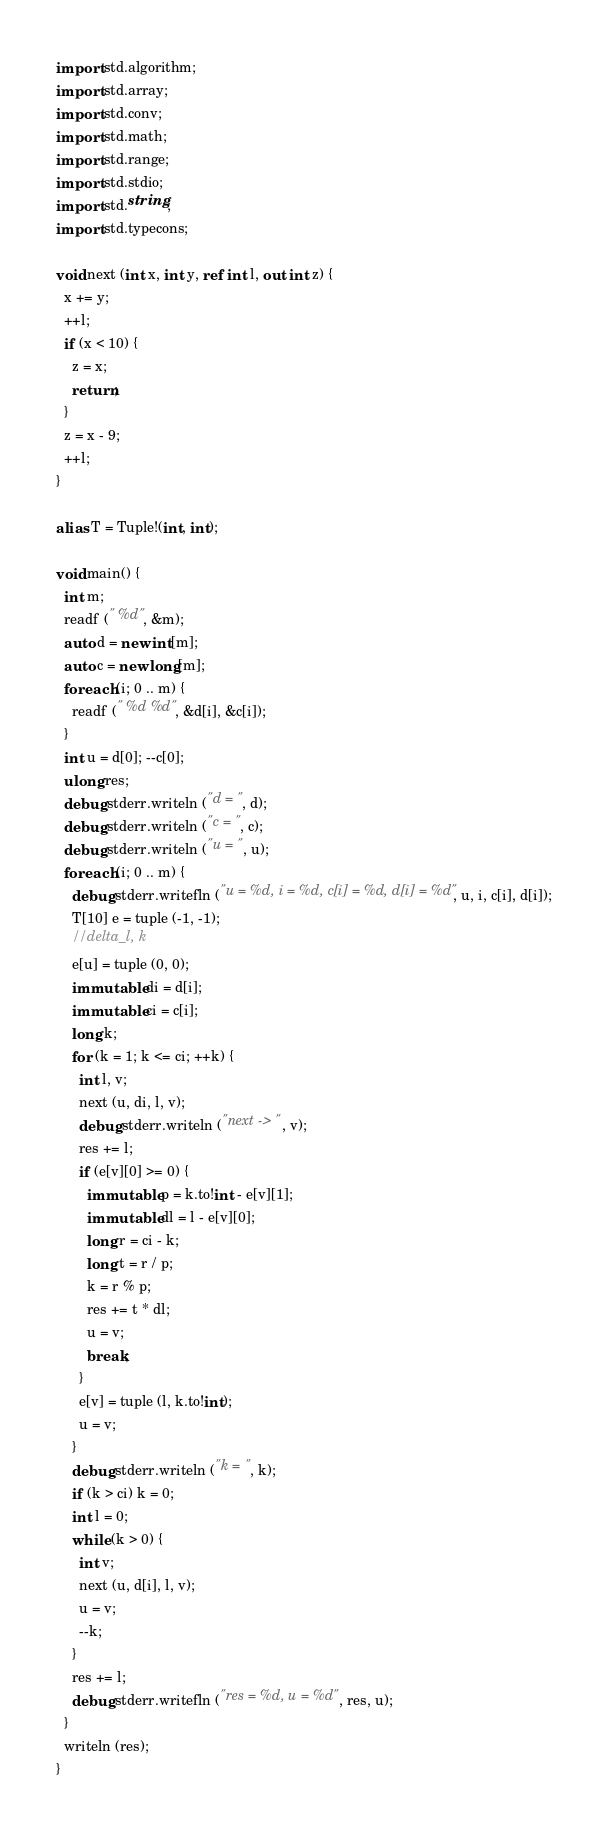Convert code to text. <code><loc_0><loc_0><loc_500><loc_500><_D_>import std.algorithm;
import std.array;
import std.conv;
import std.math;
import std.range;
import std.stdio;
import std.string;
import std.typecons;

void next (int x, int y, ref int l, out int z) {
  x += y;
  ++l;
  if (x < 10) {
    z = x;
    return;
  }
  z = x - 9;
  ++l;
}

alias T = Tuple!(int, int);

void main() {
  int m;
  readf (" %d", &m);
  auto d = new int[m];
  auto c = new long[m];
  foreach (i; 0 .. m) {
    readf (" %d %d", &d[i], &c[i]);
  }
  int u = d[0]; --c[0];
  ulong res;
  debug stderr.writeln ("d = ", d);
  debug stderr.writeln ("c = ", c);
  debug stderr.writeln ("u = ", u);
  foreach (i; 0 .. m) {
    debug stderr.writefln ("u = %d, i = %d, c[i] = %d, d[i] = %d", u, i, c[i], d[i]);
    T[10] e = tuple (-1, -1);
    //delta_l, k
    e[u] = tuple (0, 0);
    immutable di = d[i];
    immutable ci = c[i];
    long k;
    for (k = 1; k <= ci; ++k) {
      int l, v;
      next (u, di, l, v);
      debug stderr.writeln ("next -> ", v);
      res += l;
      if (e[v][0] >= 0) {
        immutable p = k.to!int - e[v][1];
        immutable dl = l - e[v][0]; 
        long r = ci - k;
        long t = r / p;
        k = r % p;
        res += t * dl;
        u = v;
        break;
      }
      e[v] = tuple (l, k.to!int);
      u = v;
    }
    debug stderr.writeln ("k = ", k);
    if (k > ci) k = 0;
    int l = 0;
    while (k > 0) {
      int v;
      next (u, d[i], l, v);
      u = v;
      --k;
    }
    res += l;
    debug stderr.writefln ("res = %d, u = %d", res, u);
  }
  writeln (res);
}

</code> 